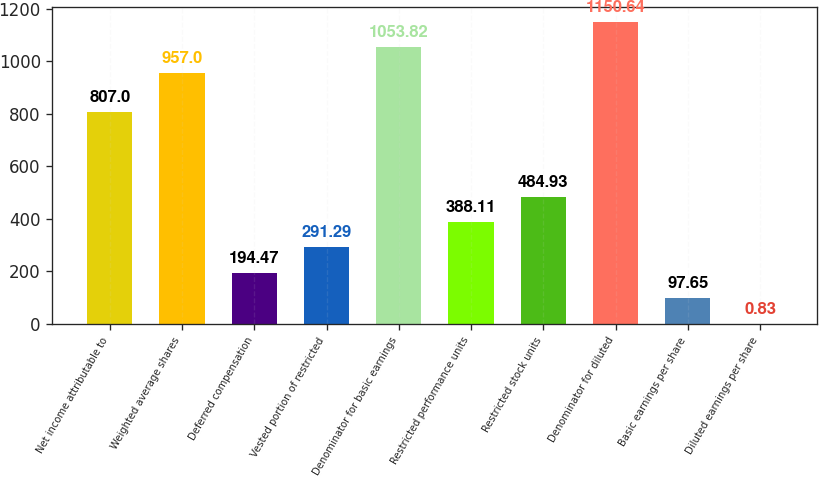Convert chart. <chart><loc_0><loc_0><loc_500><loc_500><bar_chart><fcel>Net income attributable to<fcel>Weighted average shares<fcel>Deferred compensation<fcel>Vested portion of restricted<fcel>Denominator for basic earnings<fcel>Restricted performance units<fcel>Restricted stock units<fcel>Denominator for diluted<fcel>Basic earnings per share<fcel>Diluted earnings per share<nl><fcel>807<fcel>957<fcel>194.47<fcel>291.29<fcel>1053.82<fcel>388.11<fcel>484.93<fcel>1150.64<fcel>97.65<fcel>0.83<nl></chart> 